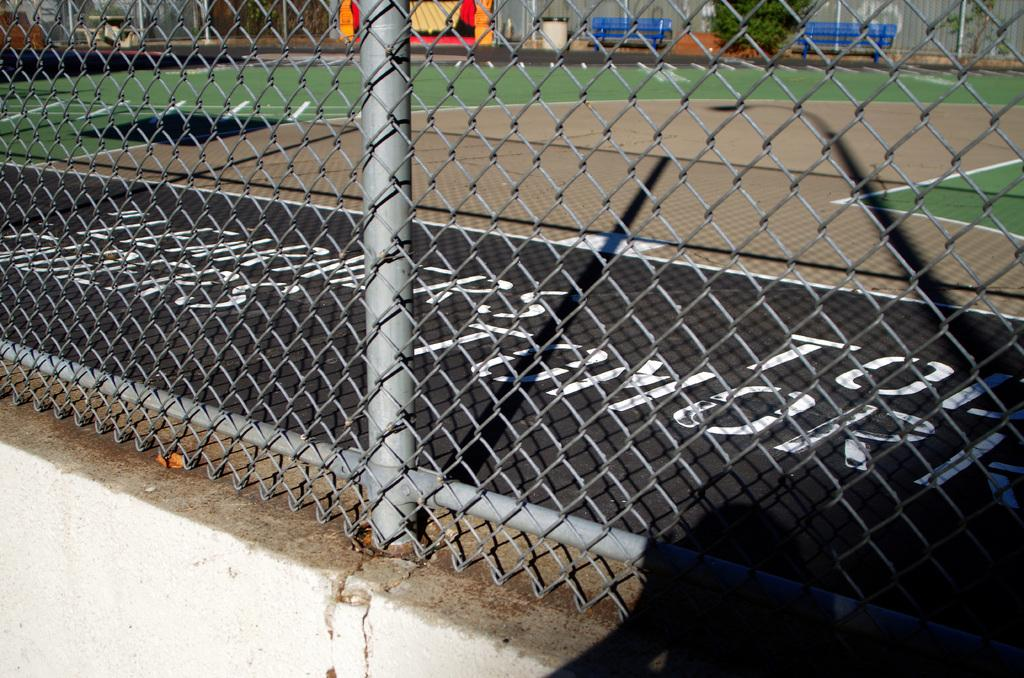What is present in the image that might be used for support or safety? There is a railing in the image. What type of seating can be seen in the background of the image? There are two blue benches in the background of the image. What type of vegetation is visible in the background of the image? There is a green tree in the background of the image. What type of sea creature can be seen swimming near the railing in the image? There is no sea creature present in the image; it is a land-based scene with a railing, benches, and a tree. 